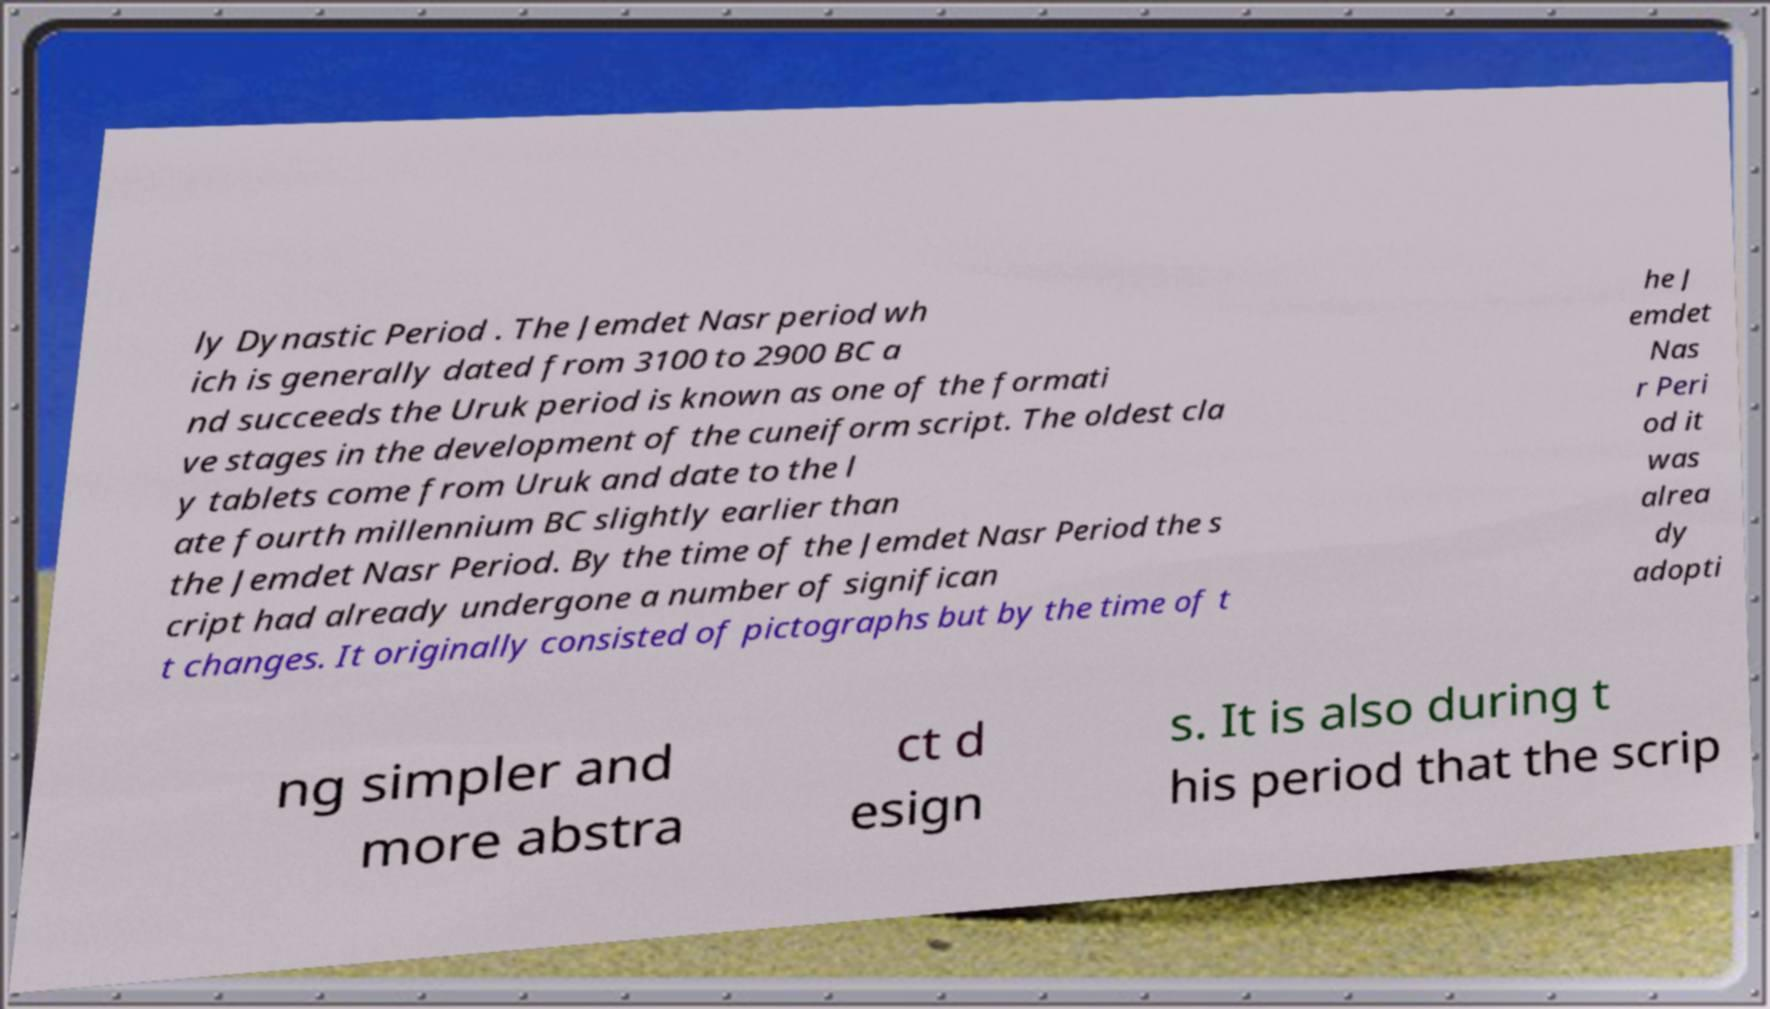Could you assist in decoding the text presented in this image and type it out clearly? ly Dynastic Period . The Jemdet Nasr period wh ich is generally dated from 3100 to 2900 BC a nd succeeds the Uruk period is known as one of the formati ve stages in the development of the cuneiform script. The oldest cla y tablets come from Uruk and date to the l ate fourth millennium BC slightly earlier than the Jemdet Nasr Period. By the time of the Jemdet Nasr Period the s cript had already undergone a number of significan t changes. It originally consisted of pictographs but by the time of t he J emdet Nas r Peri od it was alrea dy adopti ng simpler and more abstra ct d esign s. It is also during t his period that the scrip 